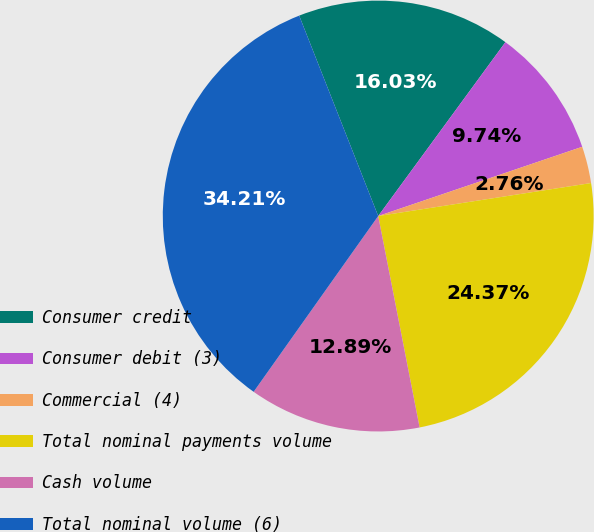Convert chart. <chart><loc_0><loc_0><loc_500><loc_500><pie_chart><fcel>Consumer credit<fcel>Consumer debit (3)<fcel>Commercial (4)<fcel>Total nominal payments volume<fcel>Cash volume<fcel>Total nominal volume (6)<nl><fcel>16.03%<fcel>9.74%<fcel>2.76%<fcel>24.37%<fcel>12.89%<fcel>34.21%<nl></chart> 